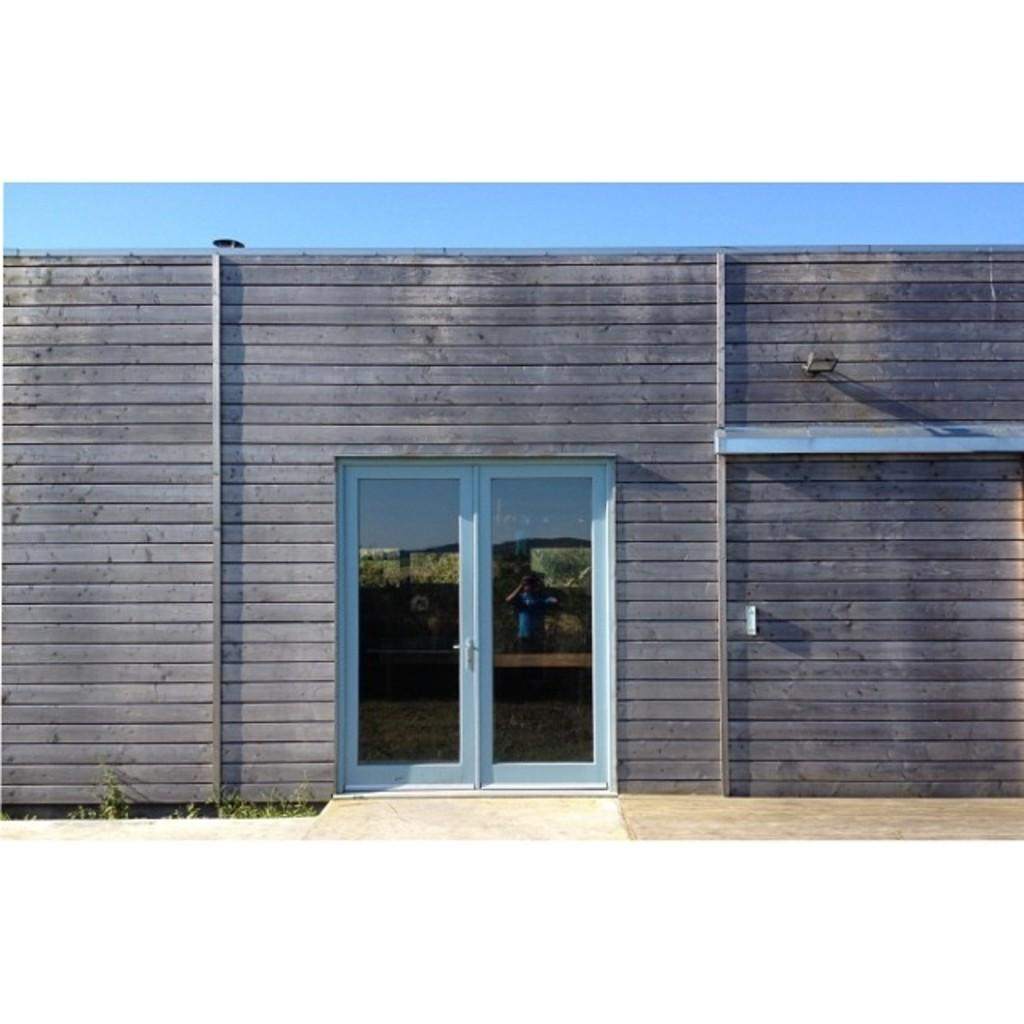What type of structure is present in the image? There is a house in the image. Can you describe any specific details about the house? The reflection of a person is visible on the glass of the doors, and there are plants visible on the glass of the doors. What can be seen in the background of the image? The sky is visible in the image. What type of crown is the stranger wearing in the image? There is no stranger or crown present in the image. 